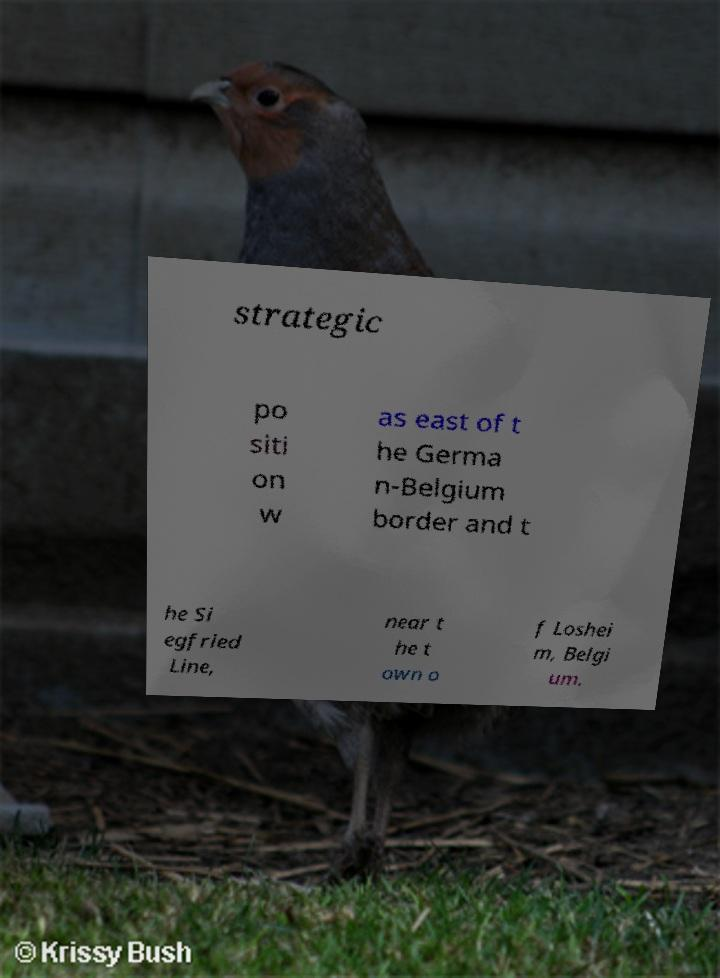Please identify and transcribe the text found in this image. strategic po siti on w as east of t he Germa n-Belgium border and t he Si egfried Line, near t he t own o f Loshei m, Belgi um. 